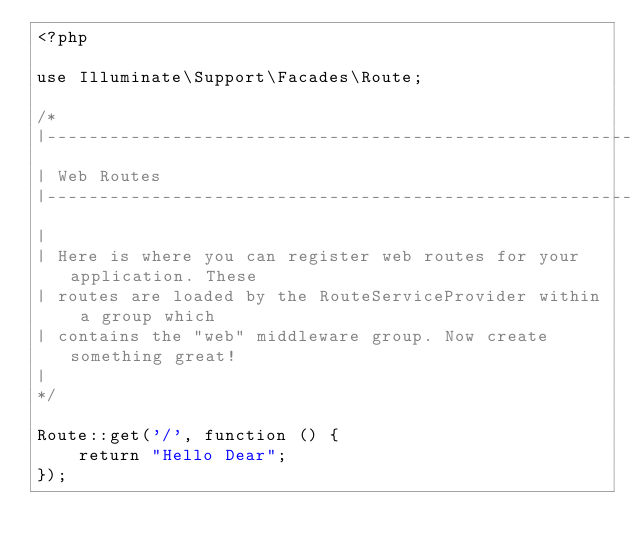<code> <loc_0><loc_0><loc_500><loc_500><_PHP_><?php

use Illuminate\Support\Facades\Route;

/*
|--------------------------------------------------------------------------
| Web Routes
|--------------------------------------------------------------------------
|
| Here is where you can register web routes for your application. These
| routes are loaded by the RouteServiceProvider within a group which
| contains the "web" middleware group. Now create something great!
|
*/

Route::get('/', function () {
    return "Hello Dear";
});
</code> 